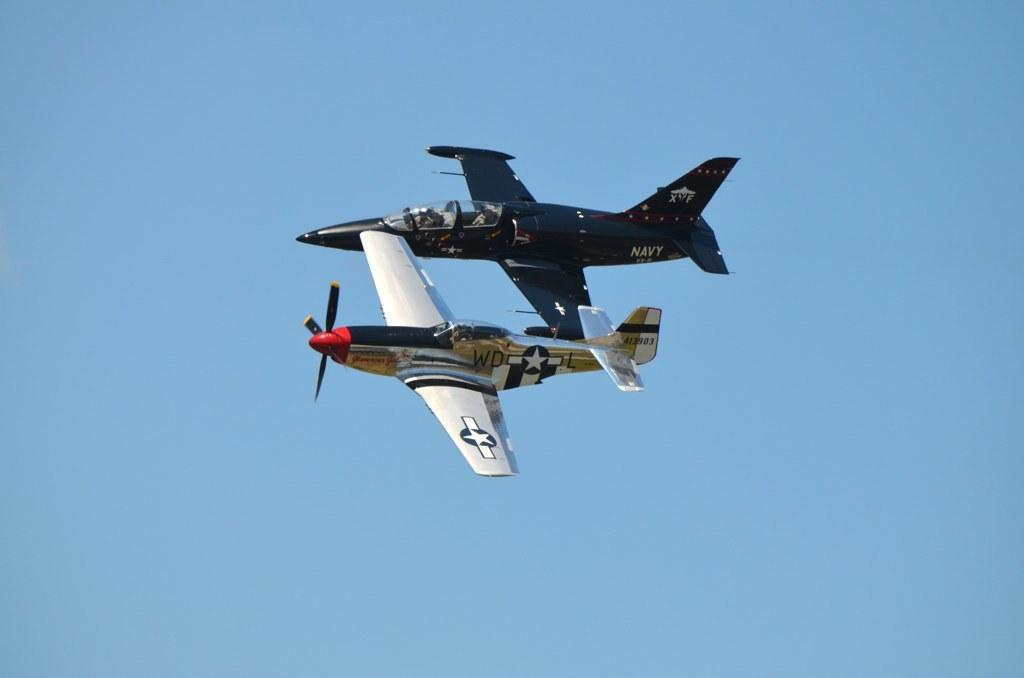What is the main subject of the image? The main subject of the image is two airplanes. Where are the airplanes located in the image? The airplanes are in the middle of the image. What can be seen in the background of the image? The sky is visible in the background of the image. Can you tell me how many calculators are visible on the seashore in the image? There are no calculators or seashore present in the image; it features two airplanes in the middle of the sky. 